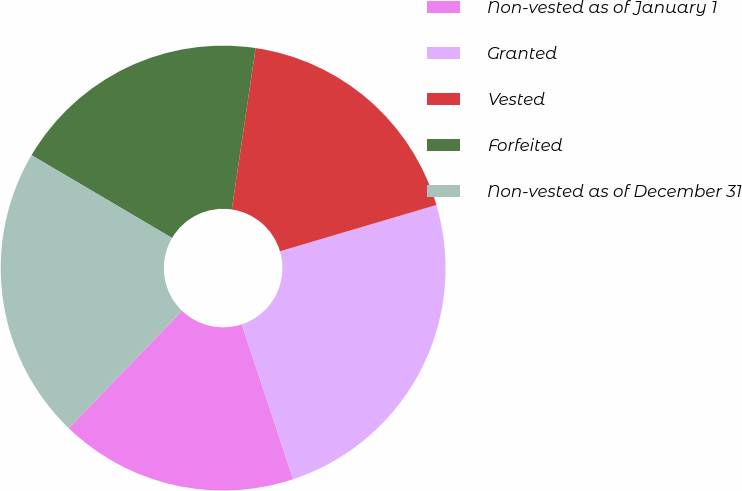Convert chart. <chart><loc_0><loc_0><loc_500><loc_500><pie_chart><fcel>Non-vested as of January 1<fcel>Granted<fcel>Vested<fcel>Forfeited<fcel>Non-vested as of December 31<nl><fcel>17.31%<fcel>24.48%<fcel>18.09%<fcel>18.86%<fcel>21.27%<nl></chart> 